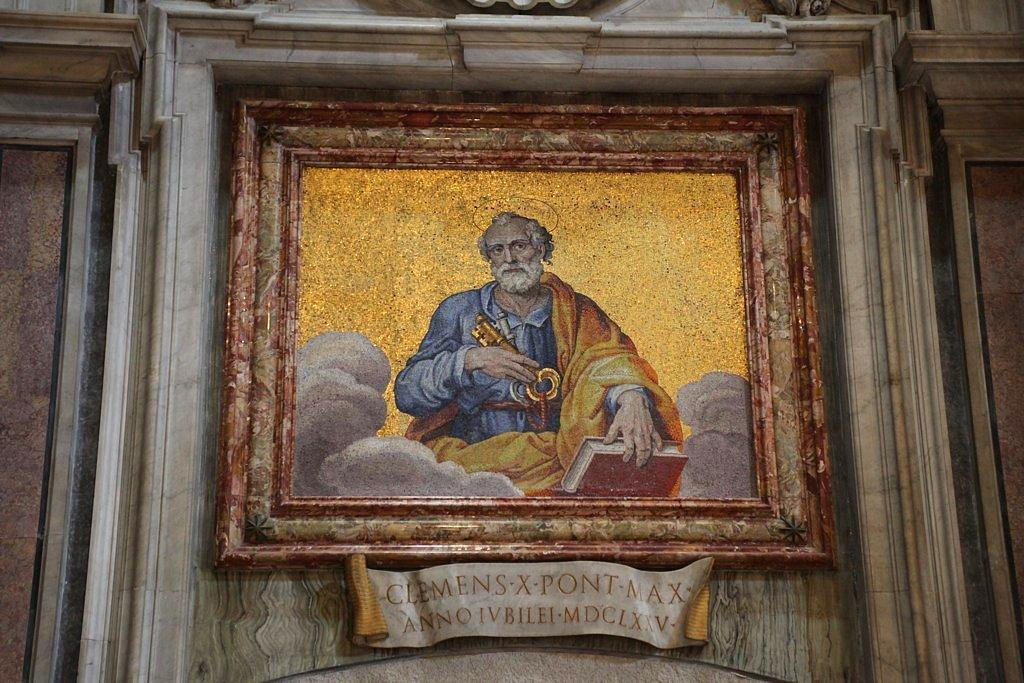<image>
Describe the image concisely. framed painting of an old man holding a book, title below the fame has clemens x pont max annoivbilei mdclxxv 